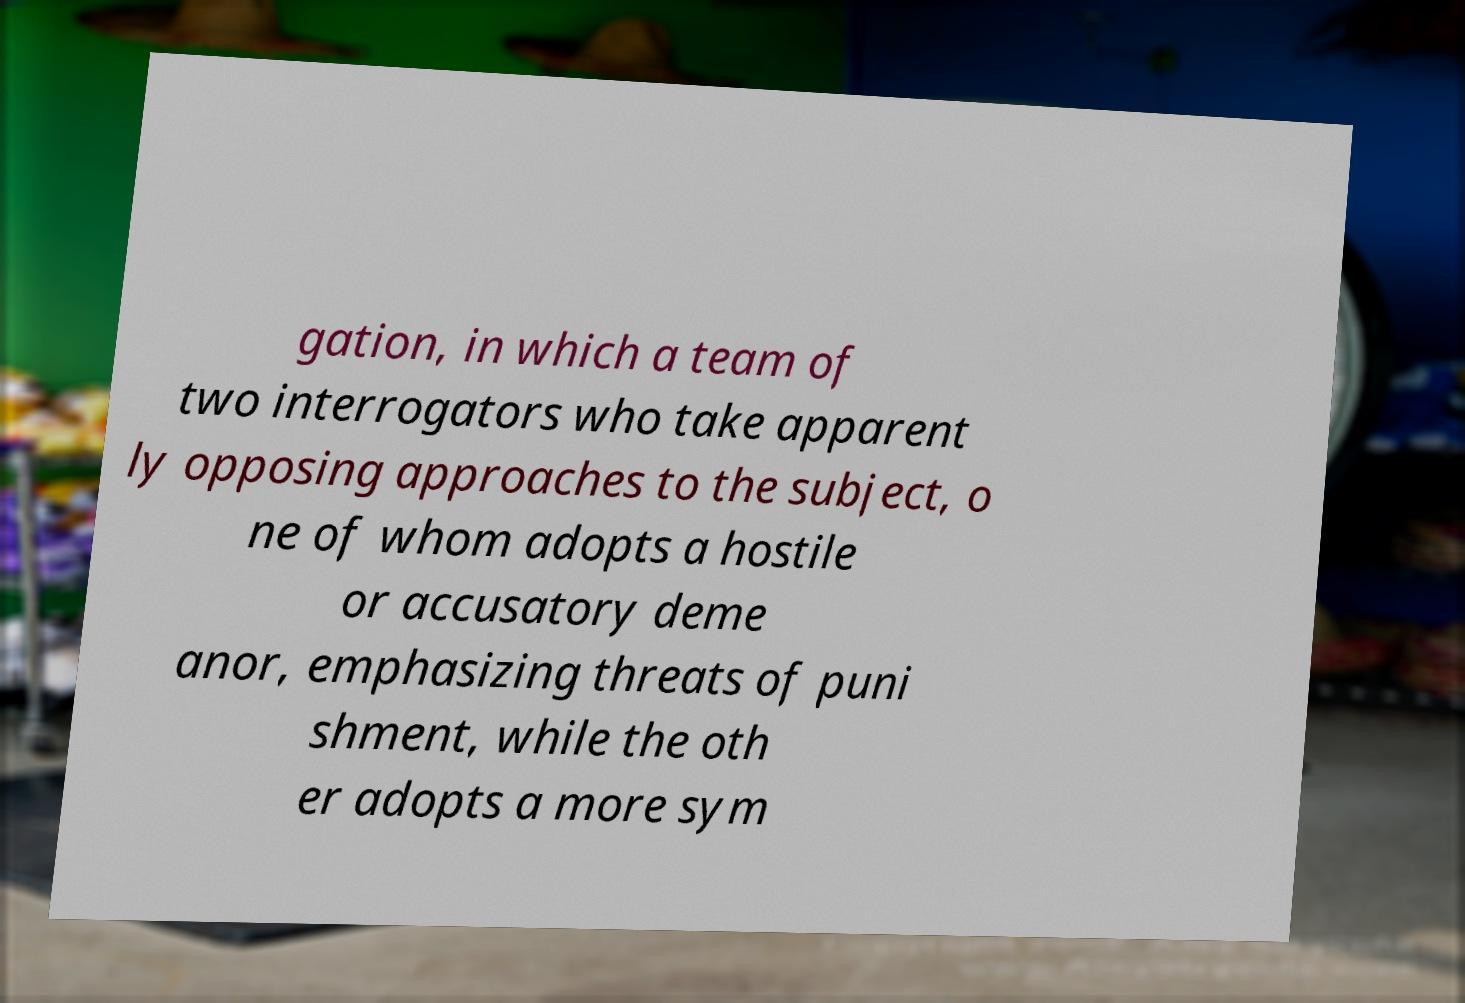There's text embedded in this image that I need extracted. Can you transcribe it verbatim? gation, in which a team of two interrogators who take apparent ly opposing approaches to the subject, o ne of whom adopts a hostile or accusatory deme anor, emphasizing threats of puni shment, while the oth er adopts a more sym 